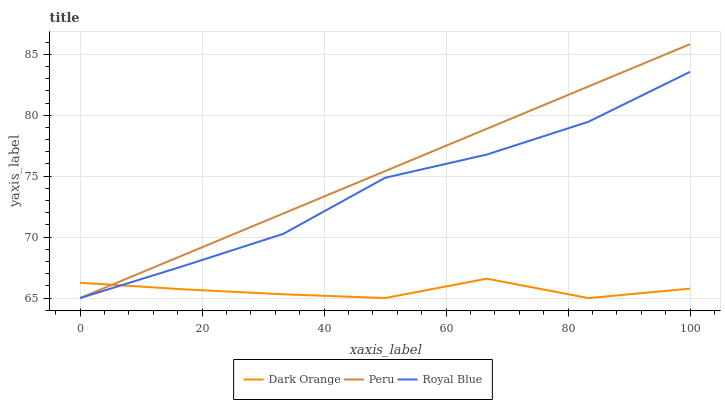Does Dark Orange have the minimum area under the curve?
Answer yes or no. Yes. Does Peru have the maximum area under the curve?
Answer yes or no. Yes. Does Royal Blue have the minimum area under the curve?
Answer yes or no. No. Does Royal Blue have the maximum area under the curve?
Answer yes or no. No. Is Peru the smoothest?
Answer yes or no. Yes. Is Dark Orange the roughest?
Answer yes or no. Yes. Is Royal Blue the smoothest?
Answer yes or no. No. Is Royal Blue the roughest?
Answer yes or no. No. Does Peru have the highest value?
Answer yes or no. Yes. Does Royal Blue have the highest value?
Answer yes or no. No. Does Peru intersect Dark Orange?
Answer yes or no. Yes. Is Peru less than Dark Orange?
Answer yes or no. No. Is Peru greater than Dark Orange?
Answer yes or no. No. 